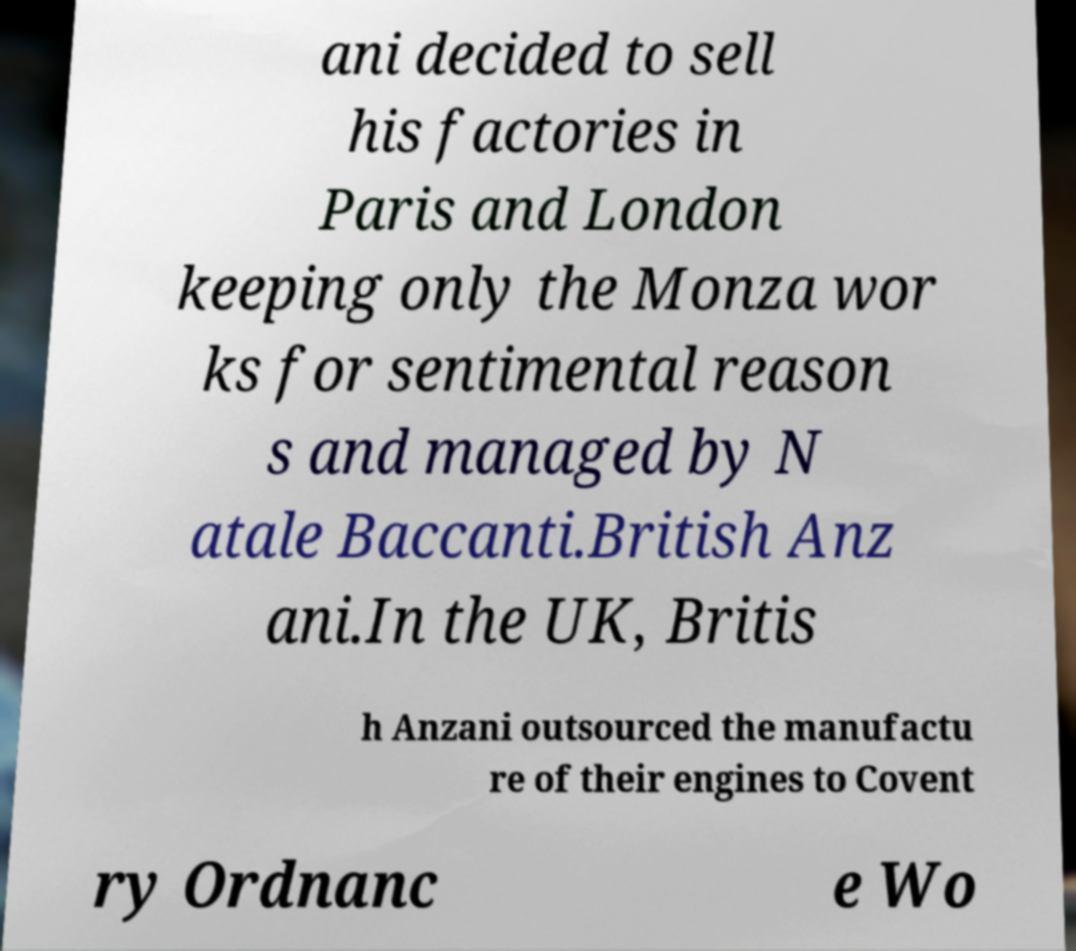I need the written content from this picture converted into text. Can you do that? ani decided to sell his factories in Paris and London keeping only the Monza wor ks for sentimental reason s and managed by N atale Baccanti.British Anz ani.In the UK, Britis h Anzani outsourced the manufactu re of their engines to Covent ry Ordnanc e Wo 